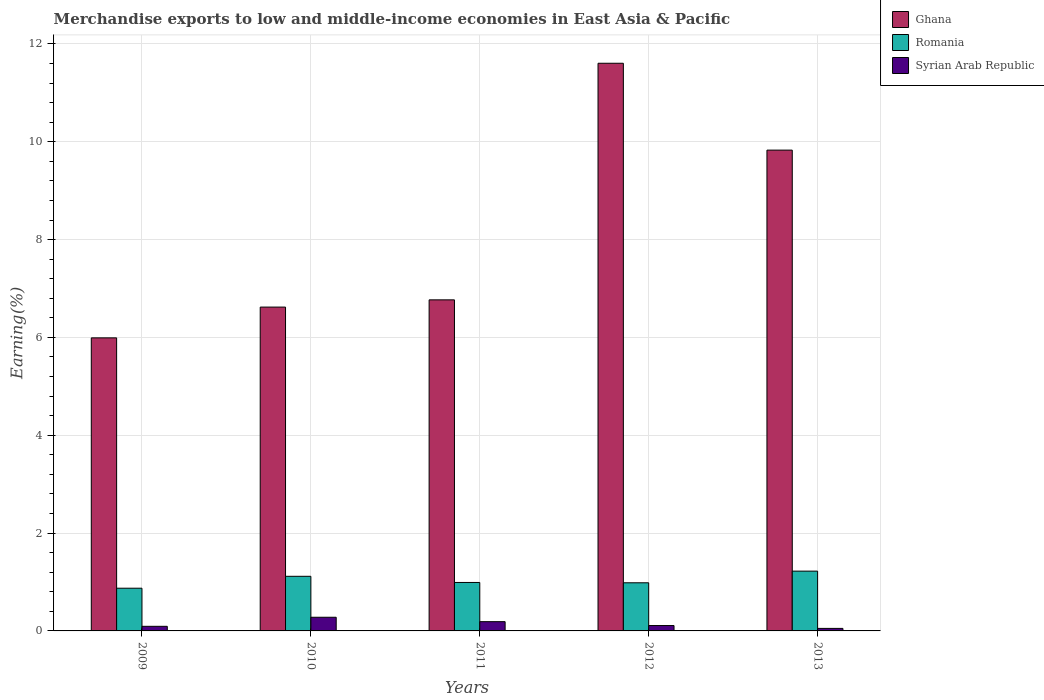Are the number of bars per tick equal to the number of legend labels?
Provide a short and direct response. Yes. How many bars are there on the 5th tick from the right?
Offer a very short reply. 3. What is the label of the 2nd group of bars from the left?
Keep it short and to the point. 2010. In how many cases, is the number of bars for a given year not equal to the number of legend labels?
Ensure brevity in your answer.  0. What is the percentage of amount earned from merchandise exports in Syrian Arab Republic in 2009?
Offer a terse response. 0.09. Across all years, what is the maximum percentage of amount earned from merchandise exports in Ghana?
Provide a short and direct response. 11.6. Across all years, what is the minimum percentage of amount earned from merchandise exports in Romania?
Make the answer very short. 0.87. In which year was the percentage of amount earned from merchandise exports in Romania maximum?
Offer a very short reply. 2013. What is the total percentage of amount earned from merchandise exports in Syrian Arab Republic in the graph?
Give a very brief answer. 0.72. What is the difference between the percentage of amount earned from merchandise exports in Ghana in 2009 and that in 2012?
Your response must be concise. -5.61. What is the difference between the percentage of amount earned from merchandise exports in Syrian Arab Republic in 2011 and the percentage of amount earned from merchandise exports in Romania in 2013?
Offer a terse response. -1.03. What is the average percentage of amount earned from merchandise exports in Syrian Arab Republic per year?
Ensure brevity in your answer.  0.14. In the year 2013, what is the difference between the percentage of amount earned from merchandise exports in Romania and percentage of amount earned from merchandise exports in Ghana?
Your response must be concise. -8.61. In how many years, is the percentage of amount earned from merchandise exports in Romania greater than 10 %?
Offer a very short reply. 0. What is the ratio of the percentage of amount earned from merchandise exports in Syrian Arab Republic in 2009 to that in 2013?
Ensure brevity in your answer.  1.83. Is the difference between the percentage of amount earned from merchandise exports in Romania in 2010 and 2013 greater than the difference between the percentage of amount earned from merchandise exports in Ghana in 2010 and 2013?
Keep it short and to the point. Yes. What is the difference between the highest and the second highest percentage of amount earned from merchandise exports in Syrian Arab Republic?
Your answer should be compact. 0.09. What is the difference between the highest and the lowest percentage of amount earned from merchandise exports in Romania?
Offer a terse response. 0.35. Is the sum of the percentage of amount earned from merchandise exports in Syrian Arab Republic in 2011 and 2013 greater than the maximum percentage of amount earned from merchandise exports in Romania across all years?
Your answer should be very brief. No. What does the 3rd bar from the left in 2009 represents?
Your response must be concise. Syrian Arab Republic. Is it the case that in every year, the sum of the percentage of amount earned from merchandise exports in Ghana and percentage of amount earned from merchandise exports in Syrian Arab Republic is greater than the percentage of amount earned from merchandise exports in Romania?
Ensure brevity in your answer.  Yes. How many bars are there?
Provide a short and direct response. 15. How many years are there in the graph?
Ensure brevity in your answer.  5. What is the difference between two consecutive major ticks on the Y-axis?
Provide a succinct answer. 2. Are the values on the major ticks of Y-axis written in scientific E-notation?
Provide a succinct answer. No. Does the graph contain grids?
Your answer should be compact. Yes. How many legend labels are there?
Ensure brevity in your answer.  3. How are the legend labels stacked?
Provide a short and direct response. Vertical. What is the title of the graph?
Make the answer very short. Merchandise exports to low and middle-income economies in East Asia & Pacific. Does "Monaco" appear as one of the legend labels in the graph?
Your answer should be very brief. No. What is the label or title of the X-axis?
Provide a short and direct response. Years. What is the label or title of the Y-axis?
Offer a very short reply. Earning(%). What is the Earning(%) of Ghana in 2009?
Offer a very short reply. 5.99. What is the Earning(%) of Romania in 2009?
Your answer should be compact. 0.87. What is the Earning(%) of Syrian Arab Republic in 2009?
Keep it short and to the point. 0.09. What is the Earning(%) in Ghana in 2010?
Offer a terse response. 6.62. What is the Earning(%) in Romania in 2010?
Provide a succinct answer. 1.12. What is the Earning(%) of Syrian Arab Republic in 2010?
Ensure brevity in your answer.  0.28. What is the Earning(%) in Ghana in 2011?
Offer a very short reply. 6.77. What is the Earning(%) of Romania in 2011?
Ensure brevity in your answer.  0.99. What is the Earning(%) in Syrian Arab Republic in 2011?
Keep it short and to the point. 0.19. What is the Earning(%) in Ghana in 2012?
Your response must be concise. 11.6. What is the Earning(%) in Romania in 2012?
Offer a terse response. 0.98. What is the Earning(%) of Syrian Arab Republic in 2012?
Offer a very short reply. 0.11. What is the Earning(%) in Ghana in 2013?
Offer a terse response. 9.83. What is the Earning(%) in Romania in 2013?
Offer a very short reply. 1.22. What is the Earning(%) in Syrian Arab Republic in 2013?
Your response must be concise. 0.05. Across all years, what is the maximum Earning(%) of Ghana?
Your answer should be compact. 11.6. Across all years, what is the maximum Earning(%) of Romania?
Give a very brief answer. 1.22. Across all years, what is the maximum Earning(%) in Syrian Arab Republic?
Your answer should be very brief. 0.28. Across all years, what is the minimum Earning(%) in Ghana?
Provide a short and direct response. 5.99. Across all years, what is the minimum Earning(%) of Romania?
Your answer should be very brief. 0.87. Across all years, what is the minimum Earning(%) of Syrian Arab Republic?
Your response must be concise. 0.05. What is the total Earning(%) of Ghana in the graph?
Your answer should be very brief. 40.81. What is the total Earning(%) in Romania in the graph?
Keep it short and to the point. 5.19. What is the total Earning(%) of Syrian Arab Republic in the graph?
Make the answer very short. 0.72. What is the difference between the Earning(%) in Ghana in 2009 and that in 2010?
Your answer should be very brief. -0.63. What is the difference between the Earning(%) in Romania in 2009 and that in 2010?
Keep it short and to the point. -0.24. What is the difference between the Earning(%) of Syrian Arab Republic in 2009 and that in 2010?
Your response must be concise. -0.19. What is the difference between the Earning(%) of Ghana in 2009 and that in 2011?
Your response must be concise. -0.78. What is the difference between the Earning(%) in Romania in 2009 and that in 2011?
Offer a terse response. -0.12. What is the difference between the Earning(%) of Syrian Arab Republic in 2009 and that in 2011?
Offer a terse response. -0.1. What is the difference between the Earning(%) of Ghana in 2009 and that in 2012?
Your answer should be very brief. -5.61. What is the difference between the Earning(%) of Romania in 2009 and that in 2012?
Ensure brevity in your answer.  -0.11. What is the difference between the Earning(%) in Syrian Arab Republic in 2009 and that in 2012?
Offer a terse response. -0.02. What is the difference between the Earning(%) of Ghana in 2009 and that in 2013?
Your response must be concise. -3.84. What is the difference between the Earning(%) in Romania in 2009 and that in 2013?
Your response must be concise. -0.35. What is the difference between the Earning(%) of Syrian Arab Republic in 2009 and that in 2013?
Provide a short and direct response. 0.04. What is the difference between the Earning(%) in Ghana in 2010 and that in 2011?
Offer a terse response. -0.15. What is the difference between the Earning(%) in Romania in 2010 and that in 2011?
Offer a terse response. 0.13. What is the difference between the Earning(%) of Syrian Arab Republic in 2010 and that in 2011?
Make the answer very short. 0.09. What is the difference between the Earning(%) of Ghana in 2010 and that in 2012?
Your answer should be very brief. -4.98. What is the difference between the Earning(%) in Romania in 2010 and that in 2012?
Provide a short and direct response. 0.13. What is the difference between the Earning(%) in Syrian Arab Republic in 2010 and that in 2012?
Keep it short and to the point. 0.17. What is the difference between the Earning(%) in Ghana in 2010 and that in 2013?
Give a very brief answer. -3.21. What is the difference between the Earning(%) of Romania in 2010 and that in 2013?
Offer a terse response. -0.11. What is the difference between the Earning(%) of Syrian Arab Republic in 2010 and that in 2013?
Provide a succinct answer. 0.23. What is the difference between the Earning(%) of Ghana in 2011 and that in 2012?
Keep it short and to the point. -4.84. What is the difference between the Earning(%) in Romania in 2011 and that in 2012?
Make the answer very short. 0.01. What is the difference between the Earning(%) in Syrian Arab Republic in 2011 and that in 2012?
Keep it short and to the point. 0.08. What is the difference between the Earning(%) of Ghana in 2011 and that in 2013?
Keep it short and to the point. -3.06. What is the difference between the Earning(%) of Romania in 2011 and that in 2013?
Your response must be concise. -0.23. What is the difference between the Earning(%) in Syrian Arab Republic in 2011 and that in 2013?
Keep it short and to the point. 0.14. What is the difference between the Earning(%) of Ghana in 2012 and that in 2013?
Offer a very short reply. 1.78. What is the difference between the Earning(%) of Romania in 2012 and that in 2013?
Offer a very short reply. -0.24. What is the difference between the Earning(%) in Syrian Arab Republic in 2012 and that in 2013?
Give a very brief answer. 0.06. What is the difference between the Earning(%) in Ghana in 2009 and the Earning(%) in Romania in 2010?
Provide a succinct answer. 4.87. What is the difference between the Earning(%) in Ghana in 2009 and the Earning(%) in Syrian Arab Republic in 2010?
Provide a succinct answer. 5.71. What is the difference between the Earning(%) of Romania in 2009 and the Earning(%) of Syrian Arab Republic in 2010?
Keep it short and to the point. 0.59. What is the difference between the Earning(%) of Ghana in 2009 and the Earning(%) of Romania in 2011?
Offer a terse response. 5. What is the difference between the Earning(%) in Ghana in 2009 and the Earning(%) in Syrian Arab Republic in 2011?
Provide a succinct answer. 5.8. What is the difference between the Earning(%) in Romania in 2009 and the Earning(%) in Syrian Arab Republic in 2011?
Make the answer very short. 0.68. What is the difference between the Earning(%) in Ghana in 2009 and the Earning(%) in Romania in 2012?
Offer a very short reply. 5.01. What is the difference between the Earning(%) in Ghana in 2009 and the Earning(%) in Syrian Arab Republic in 2012?
Make the answer very short. 5.88. What is the difference between the Earning(%) in Romania in 2009 and the Earning(%) in Syrian Arab Republic in 2012?
Give a very brief answer. 0.76. What is the difference between the Earning(%) in Ghana in 2009 and the Earning(%) in Romania in 2013?
Give a very brief answer. 4.77. What is the difference between the Earning(%) of Ghana in 2009 and the Earning(%) of Syrian Arab Republic in 2013?
Offer a terse response. 5.94. What is the difference between the Earning(%) of Romania in 2009 and the Earning(%) of Syrian Arab Republic in 2013?
Keep it short and to the point. 0.82. What is the difference between the Earning(%) of Ghana in 2010 and the Earning(%) of Romania in 2011?
Make the answer very short. 5.63. What is the difference between the Earning(%) of Ghana in 2010 and the Earning(%) of Syrian Arab Republic in 2011?
Ensure brevity in your answer.  6.43. What is the difference between the Earning(%) in Romania in 2010 and the Earning(%) in Syrian Arab Republic in 2011?
Provide a short and direct response. 0.93. What is the difference between the Earning(%) of Ghana in 2010 and the Earning(%) of Romania in 2012?
Make the answer very short. 5.64. What is the difference between the Earning(%) in Ghana in 2010 and the Earning(%) in Syrian Arab Republic in 2012?
Make the answer very short. 6.51. What is the difference between the Earning(%) in Romania in 2010 and the Earning(%) in Syrian Arab Republic in 2012?
Provide a succinct answer. 1.01. What is the difference between the Earning(%) in Ghana in 2010 and the Earning(%) in Romania in 2013?
Your answer should be very brief. 5.4. What is the difference between the Earning(%) of Ghana in 2010 and the Earning(%) of Syrian Arab Republic in 2013?
Give a very brief answer. 6.57. What is the difference between the Earning(%) in Romania in 2010 and the Earning(%) in Syrian Arab Republic in 2013?
Your response must be concise. 1.06. What is the difference between the Earning(%) of Ghana in 2011 and the Earning(%) of Romania in 2012?
Offer a terse response. 5.78. What is the difference between the Earning(%) of Ghana in 2011 and the Earning(%) of Syrian Arab Republic in 2012?
Make the answer very short. 6.66. What is the difference between the Earning(%) of Romania in 2011 and the Earning(%) of Syrian Arab Republic in 2012?
Your answer should be very brief. 0.88. What is the difference between the Earning(%) in Ghana in 2011 and the Earning(%) in Romania in 2013?
Your response must be concise. 5.55. What is the difference between the Earning(%) in Ghana in 2011 and the Earning(%) in Syrian Arab Republic in 2013?
Offer a terse response. 6.72. What is the difference between the Earning(%) in Romania in 2011 and the Earning(%) in Syrian Arab Republic in 2013?
Your answer should be very brief. 0.94. What is the difference between the Earning(%) of Ghana in 2012 and the Earning(%) of Romania in 2013?
Provide a short and direct response. 10.38. What is the difference between the Earning(%) of Ghana in 2012 and the Earning(%) of Syrian Arab Republic in 2013?
Offer a terse response. 11.55. What is the difference between the Earning(%) of Romania in 2012 and the Earning(%) of Syrian Arab Republic in 2013?
Your answer should be compact. 0.93. What is the average Earning(%) of Ghana per year?
Give a very brief answer. 8.16. What is the average Earning(%) of Romania per year?
Provide a short and direct response. 1.04. What is the average Earning(%) of Syrian Arab Republic per year?
Provide a succinct answer. 0.14. In the year 2009, what is the difference between the Earning(%) of Ghana and Earning(%) of Romania?
Offer a terse response. 5.12. In the year 2009, what is the difference between the Earning(%) of Ghana and Earning(%) of Syrian Arab Republic?
Give a very brief answer. 5.9. In the year 2009, what is the difference between the Earning(%) in Romania and Earning(%) in Syrian Arab Republic?
Your response must be concise. 0.78. In the year 2010, what is the difference between the Earning(%) in Ghana and Earning(%) in Romania?
Provide a short and direct response. 5.5. In the year 2010, what is the difference between the Earning(%) in Ghana and Earning(%) in Syrian Arab Republic?
Keep it short and to the point. 6.34. In the year 2010, what is the difference between the Earning(%) of Romania and Earning(%) of Syrian Arab Republic?
Your response must be concise. 0.84. In the year 2011, what is the difference between the Earning(%) in Ghana and Earning(%) in Romania?
Your answer should be very brief. 5.78. In the year 2011, what is the difference between the Earning(%) of Ghana and Earning(%) of Syrian Arab Republic?
Your response must be concise. 6.58. In the year 2011, what is the difference between the Earning(%) in Romania and Earning(%) in Syrian Arab Republic?
Offer a terse response. 0.8. In the year 2012, what is the difference between the Earning(%) in Ghana and Earning(%) in Romania?
Provide a short and direct response. 10.62. In the year 2012, what is the difference between the Earning(%) of Ghana and Earning(%) of Syrian Arab Republic?
Make the answer very short. 11.49. In the year 2012, what is the difference between the Earning(%) in Romania and Earning(%) in Syrian Arab Republic?
Your answer should be very brief. 0.87. In the year 2013, what is the difference between the Earning(%) of Ghana and Earning(%) of Romania?
Offer a very short reply. 8.61. In the year 2013, what is the difference between the Earning(%) of Ghana and Earning(%) of Syrian Arab Republic?
Keep it short and to the point. 9.78. In the year 2013, what is the difference between the Earning(%) in Romania and Earning(%) in Syrian Arab Republic?
Give a very brief answer. 1.17. What is the ratio of the Earning(%) of Ghana in 2009 to that in 2010?
Offer a terse response. 0.91. What is the ratio of the Earning(%) in Romania in 2009 to that in 2010?
Offer a terse response. 0.78. What is the ratio of the Earning(%) in Syrian Arab Republic in 2009 to that in 2010?
Offer a terse response. 0.34. What is the ratio of the Earning(%) of Ghana in 2009 to that in 2011?
Keep it short and to the point. 0.89. What is the ratio of the Earning(%) of Romania in 2009 to that in 2011?
Your response must be concise. 0.88. What is the ratio of the Earning(%) in Syrian Arab Republic in 2009 to that in 2011?
Your answer should be compact. 0.5. What is the ratio of the Earning(%) in Ghana in 2009 to that in 2012?
Your answer should be very brief. 0.52. What is the ratio of the Earning(%) in Romania in 2009 to that in 2012?
Provide a short and direct response. 0.89. What is the ratio of the Earning(%) in Syrian Arab Republic in 2009 to that in 2012?
Your answer should be very brief. 0.86. What is the ratio of the Earning(%) in Ghana in 2009 to that in 2013?
Provide a short and direct response. 0.61. What is the ratio of the Earning(%) of Romania in 2009 to that in 2013?
Provide a succinct answer. 0.71. What is the ratio of the Earning(%) of Syrian Arab Republic in 2009 to that in 2013?
Your answer should be compact. 1.83. What is the ratio of the Earning(%) in Ghana in 2010 to that in 2011?
Offer a very short reply. 0.98. What is the ratio of the Earning(%) in Romania in 2010 to that in 2011?
Offer a very short reply. 1.13. What is the ratio of the Earning(%) of Syrian Arab Republic in 2010 to that in 2011?
Your answer should be compact. 1.47. What is the ratio of the Earning(%) in Ghana in 2010 to that in 2012?
Give a very brief answer. 0.57. What is the ratio of the Earning(%) of Romania in 2010 to that in 2012?
Provide a short and direct response. 1.13. What is the ratio of the Earning(%) in Syrian Arab Republic in 2010 to that in 2012?
Your answer should be compact. 2.54. What is the ratio of the Earning(%) of Ghana in 2010 to that in 2013?
Provide a short and direct response. 0.67. What is the ratio of the Earning(%) of Romania in 2010 to that in 2013?
Keep it short and to the point. 0.91. What is the ratio of the Earning(%) of Syrian Arab Republic in 2010 to that in 2013?
Provide a succinct answer. 5.42. What is the ratio of the Earning(%) of Ghana in 2011 to that in 2012?
Give a very brief answer. 0.58. What is the ratio of the Earning(%) in Romania in 2011 to that in 2012?
Make the answer very short. 1.01. What is the ratio of the Earning(%) of Syrian Arab Republic in 2011 to that in 2012?
Your answer should be compact. 1.72. What is the ratio of the Earning(%) in Ghana in 2011 to that in 2013?
Offer a very short reply. 0.69. What is the ratio of the Earning(%) of Romania in 2011 to that in 2013?
Provide a short and direct response. 0.81. What is the ratio of the Earning(%) of Syrian Arab Republic in 2011 to that in 2013?
Your answer should be compact. 3.68. What is the ratio of the Earning(%) in Ghana in 2012 to that in 2013?
Your answer should be very brief. 1.18. What is the ratio of the Earning(%) of Romania in 2012 to that in 2013?
Your answer should be compact. 0.81. What is the ratio of the Earning(%) in Syrian Arab Republic in 2012 to that in 2013?
Your response must be concise. 2.13. What is the difference between the highest and the second highest Earning(%) of Ghana?
Offer a very short reply. 1.78. What is the difference between the highest and the second highest Earning(%) of Romania?
Provide a succinct answer. 0.11. What is the difference between the highest and the second highest Earning(%) of Syrian Arab Republic?
Keep it short and to the point. 0.09. What is the difference between the highest and the lowest Earning(%) in Ghana?
Offer a very short reply. 5.61. What is the difference between the highest and the lowest Earning(%) of Romania?
Offer a very short reply. 0.35. What is the difference between the highest and the lowest Earning(%) in Syrian Arab Republic?
Make the answer very short. 0.23. 